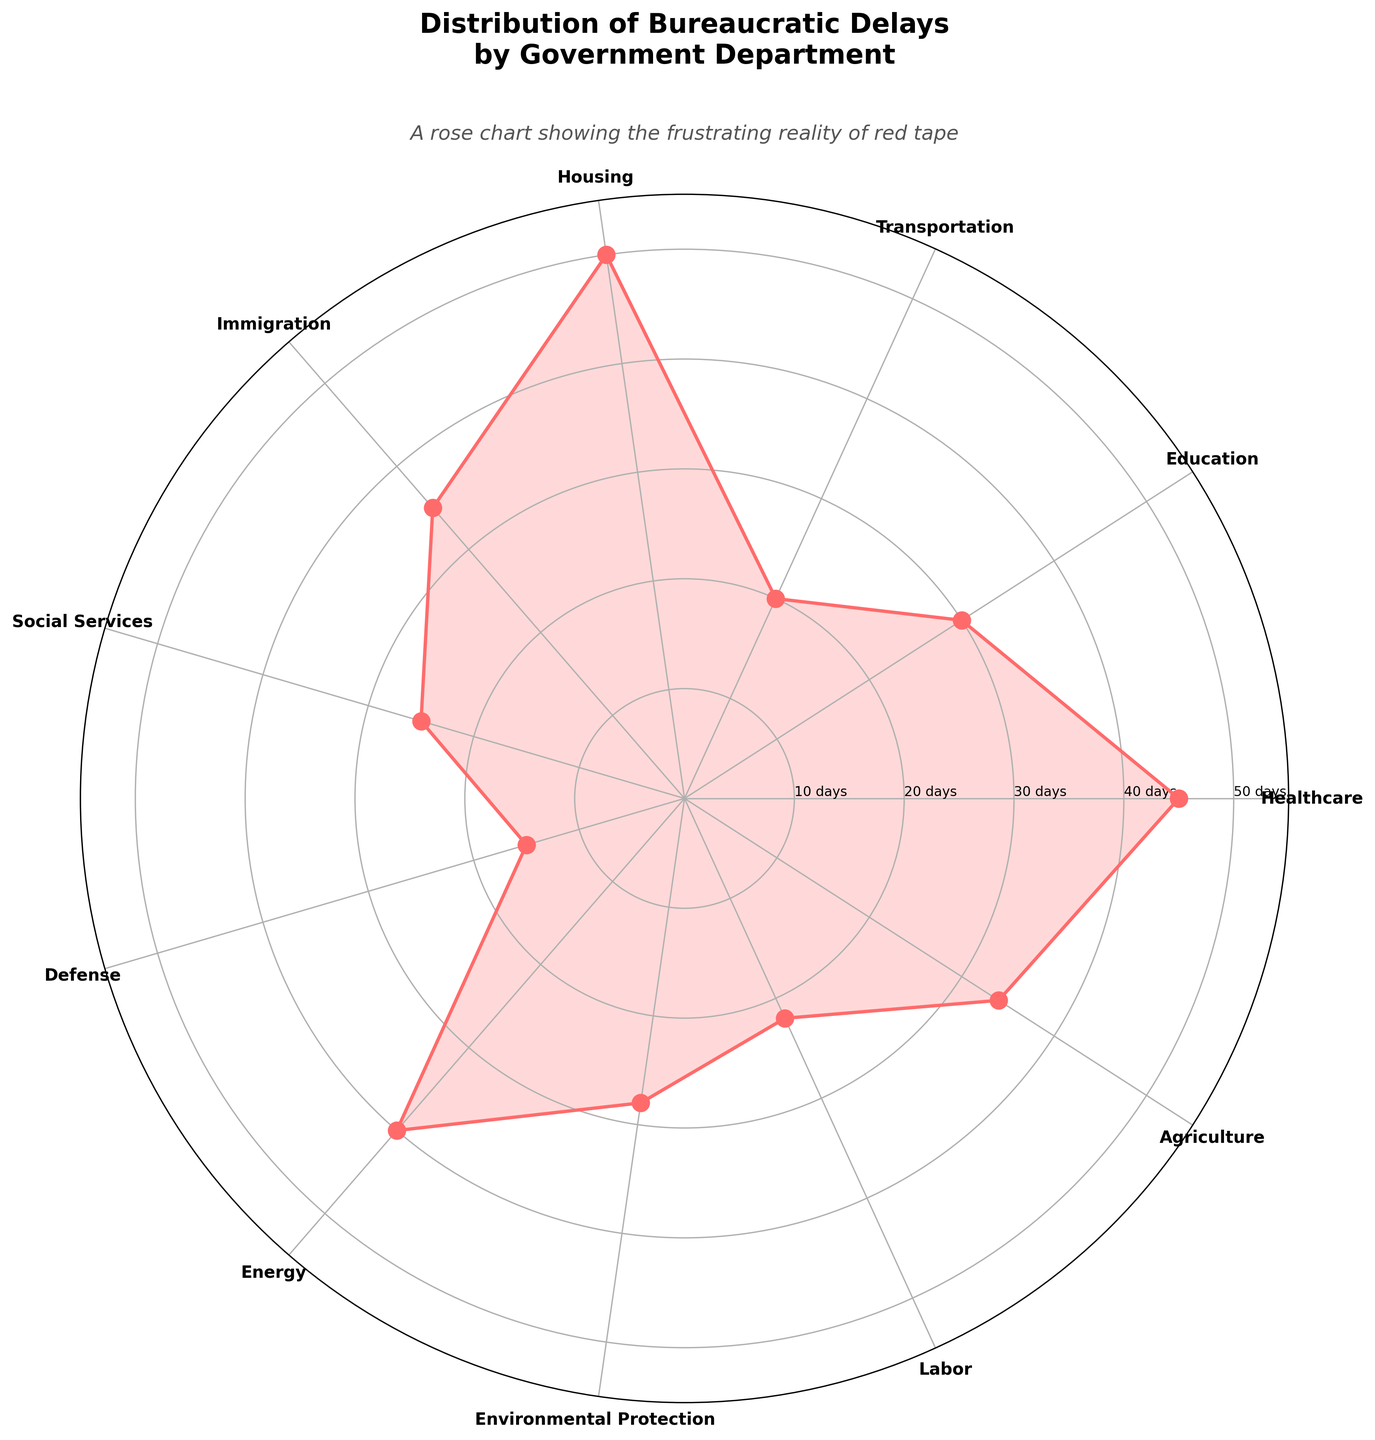What is the title of the chart? The title of the chart is usually found at the top and provides the main description of the chart. In this case, the title should be placed prominently above the rose chart.
Answer: Distribution of Bureaucratic Delays by Government Department Which department has the highest bureaucratic delay? To identify the department with the highest delay, look for the segment of the rose chart that extends the furthest from the center. Here, we see that the Housing department extends the most.
Answer: Housing How many days does the Defense department delay on average? Locate the segment corresponding to the Defense department in the rose chart and check the numerical label associated with this segment.
Answer: 15 days What is the difference in delay days between the Healthcare and Education departments? Find the segments for both Healthcare and Education, note their delay days, and subtract the smaller number from the larger number: 45 days (Healthcare) - 30 days (Education).
Answer: 15 days How many departments have a bureaucratic delay of 30 days or more? Count the number of departments that have segments extending to 30 days or more in the rose chart. Departments: Healthcare, Education, Housing, Immigration, Energy, Environmental Protection, Agriculture.
Answer: 7 departments Which department has the least amount of bureaucratic delay? Identify the segment that is closest to the center of the rose chart. This represents the department with the least delay days.
Answer: Defense What color is used to represent the delays in the chart? The color used to represent the delays is consistent throughout the chart. This color fills the area between the segments and the origin.
Answer: Pinkish-red (described as #FF6B6B) What is the average delay across all departments? Sum all the delay days and divide by the number of departments: (45 + 30 + 20 + 50 + 35 + 25 + 15 + 40 + 28 + 22 + 34) / 11.
Answer: 31.36 days How does the delay for Agriculture compare to Healthcare? Check the segments for Agriculture and Healthcare. Agriculture has 34 days and Healthcare has 45 days, so Healthcare has a greater delay than Agriculture.
Answer: Healthcare has greater delay What is the median delay among the departments? To find the median, list out all delay days and find the middle value when the list is ordered: [15, 20, 22, 25, 28, 30, 34, 35, 40, 45, 50].
Answer: 30 days 